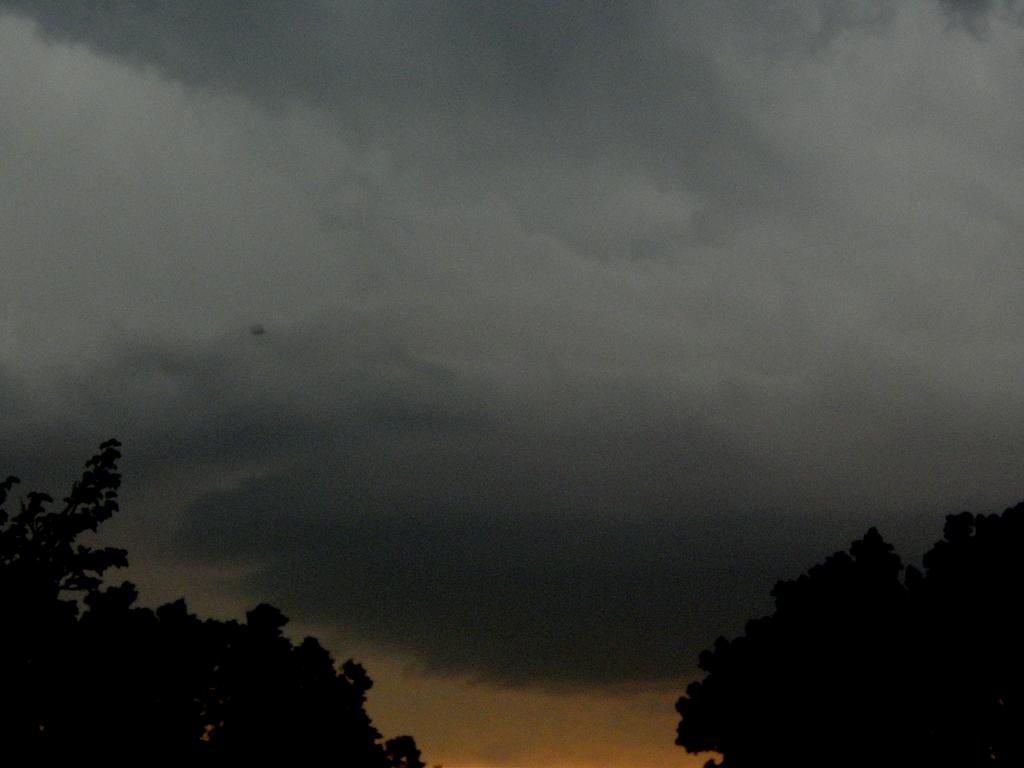What type of vegetation can be seen at the bottom of the image? There are trees on the right and left bottom of the image. What is visible at the top of the image? The sky is visible at the top of the image. Can you describe the sky in the image? The sky appears to be cloudy. How many cacti are present in the image? There are no cacti present in the image; it features trees and a cloudy sky. What type of roll can be seen in the image? There is no roll present in the image. 